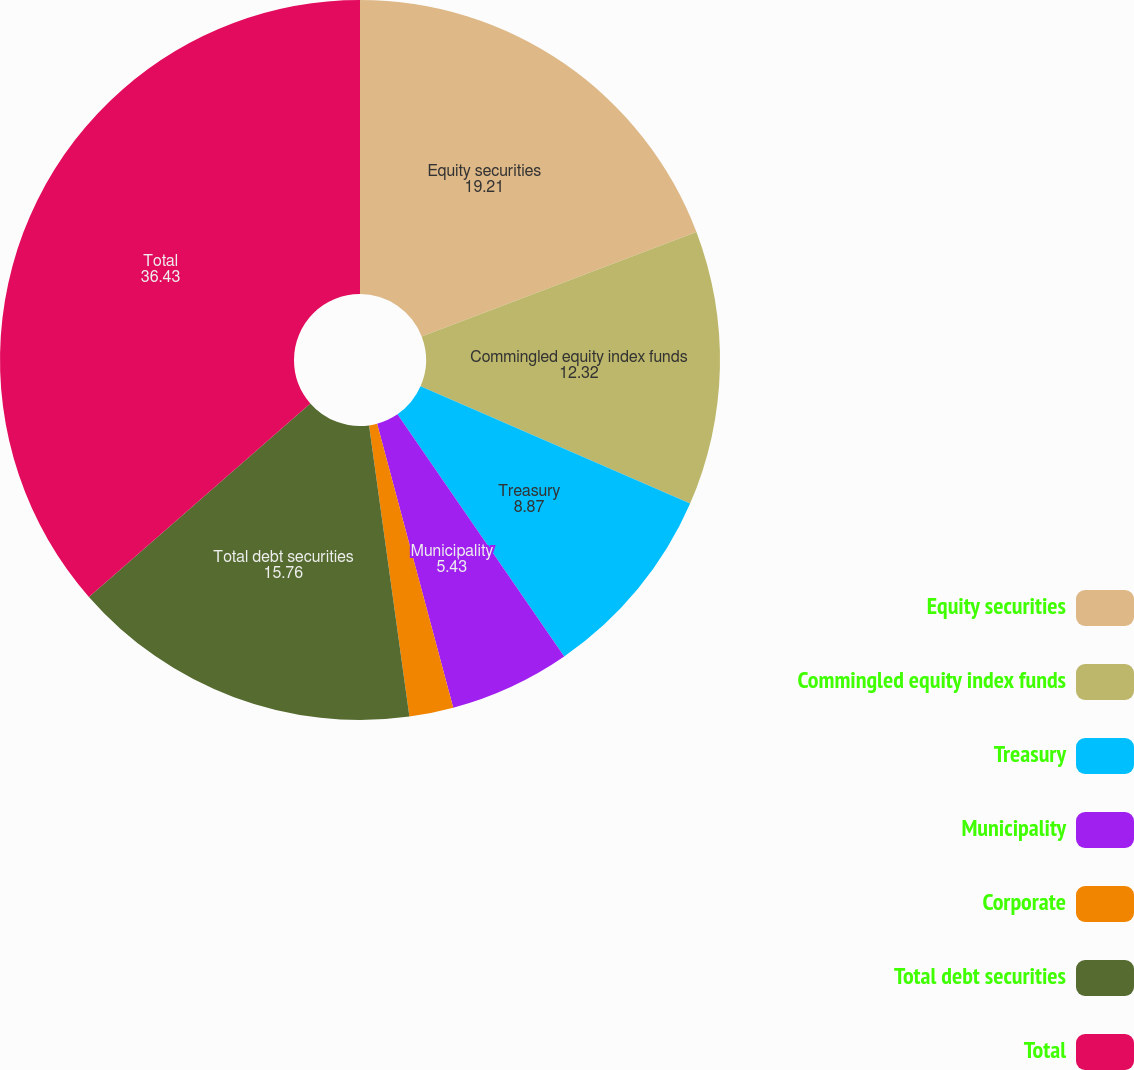<chart> <loc_0><loc_0><loc_500><loc_500><pie_chart><fcel>Equity securities<fcel>Commingled equity index funds<fcel>Treasury<fcel>Municipality<fcel>Corporate<fcel>Total debt securities<fcel>Total<nl><fcel>19.21%<fcel>12.32%<fcel>8.87%<fcel>5.43%<fcel>1.98%<fcel>15.76%<fcel>36.43%<nl></chart> 